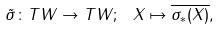Convert formula to latex. <formula><loc_0><loc_0><loc_500><loc_500>\tilde { \sigma } \colon T W \to T W ; \ X \mapsto \overline { \sigma _ { * } ( X ) } ,</formula> 